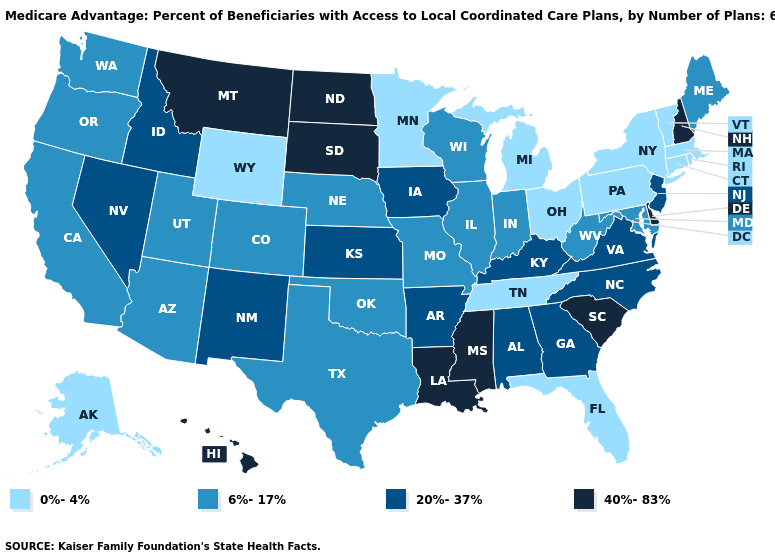What is the value of South Carolina?
Give a very brief answer. 40%-83%. Does Utah have the highest value in the USA?
Short answer required. No. Which states have the lowest value in the USA?
Keep it brief. Connecticut, Florida, Massachusetts, Michigan, Minnesota, New York, Ohio, Pennsylvania, Rhode Island, Alaska, Tennessee, Vermont, Wyoming. Name the states that have a value in the range 40%-83%?
Give a very brief answer. Delaware, Hawaii, Louisiana, Mississippi, Montana, North Dakota, New Hampshire, South Carolina, South Dakota. Does Hawaii have a lower value than Vermont?
Keep it brief. No. What is the value of Idaho?
Concise answer only. 20%-37%. What is the value of Tennessee?
Be succinct. 0%-4%. Name the states that have a value in the range 0%-4%?
Answer briefly. Connecticut, Florida, Massachusetts, Michigan, Minnesota, New York, Ohio, Pennsylvania, Rhode Island, Alaska, Tennessee, Vermont, Wyoming. What is the value of Nevada?
Short answer required. 20%-37%. What is the highest value in the USA?
Answer briefly. 40%-83%. What is the highest value in the Northeast ?
Keep it brief. 40%-83%. Does Oregon have a lower value than Alabama?
Keep it brief. Yes. Does the map have missing data?
Be succinct. No. Name the states that have a value in the range 40%-83%?
Write a very short answer. Delaware, Hawaii, Louisiana, Mississippi, Montana, North Dakota, New Hampshire, South Carolina, South Dakota. What is the value of Massachusetts?
Give a very brief answer. 0%-4%. 